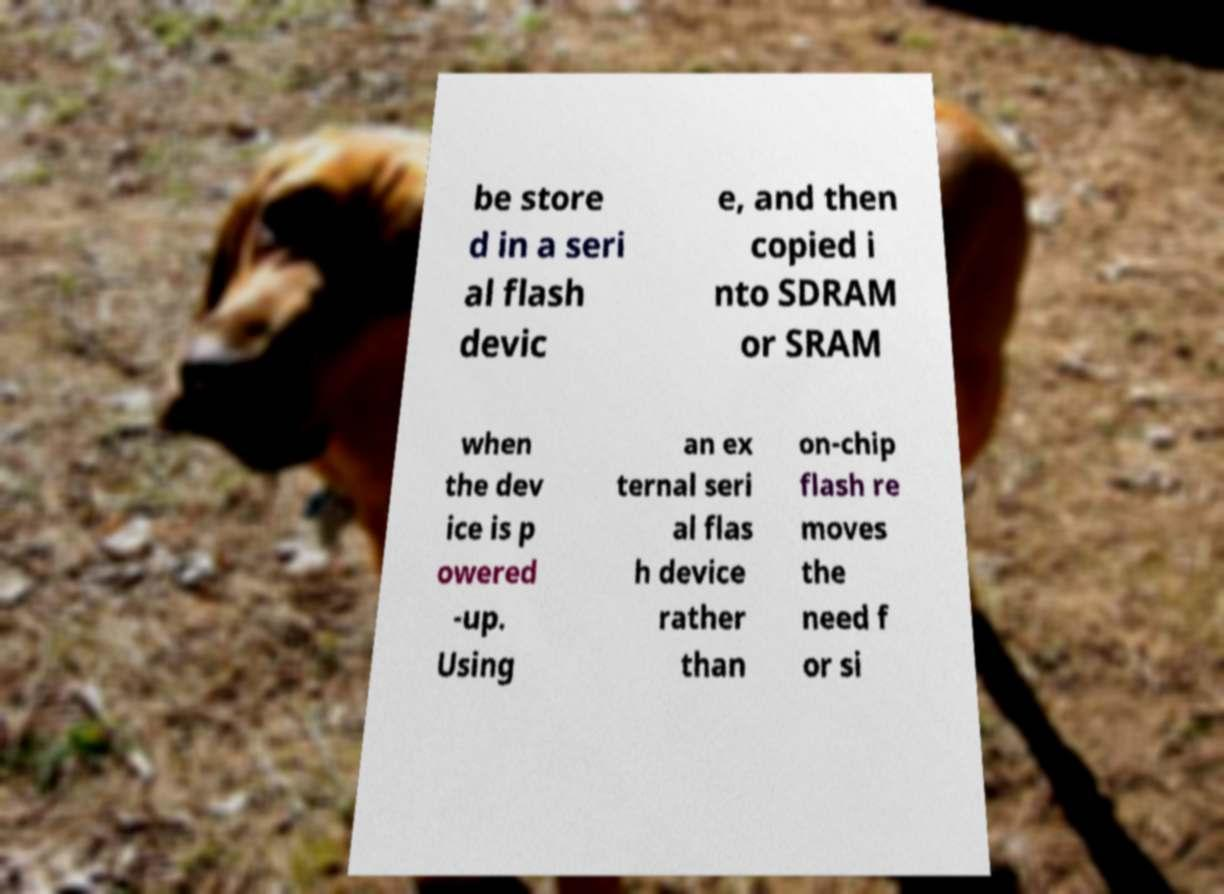Can you read and provide the text displayed in the image?This photo seems to have some interesting text. Can you extract and type it out for me? be store d in a seri al flash devic e, and then copied i nto SDRAM or SRAM when the dev ice is p owered -up. Using an ex ternal seri al flas h device rather than on-chip flash re moves the need f or si 